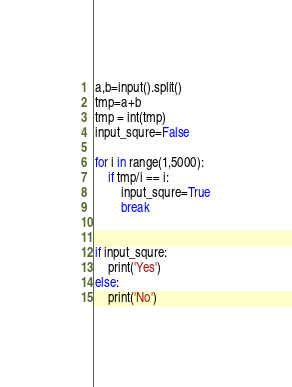Convert code to text. <code><loc_0><loc_0><loc_500><loc_500><_Python_>a,b=input().split()
tmp=a+b
tmp = int(tmp)
input_squre=False

for i in range(1,5000):
    if tmp/i == i:
        input_squre=True
        break


if input_squre:
    print('Yes')
else:
    print('No')


</code> 